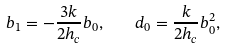Convert formula to latex. <formula><loc_0><loc_0><loc_500><loc_500>b _ { 1 } = - \frac { 3 k } { 2 h _ { c } } b _ { 0 } , \quad d _ { 0 } = \frac { k } { 2 h _ { c } } b _ { 0 } ^ { 2 } ,</formula> 